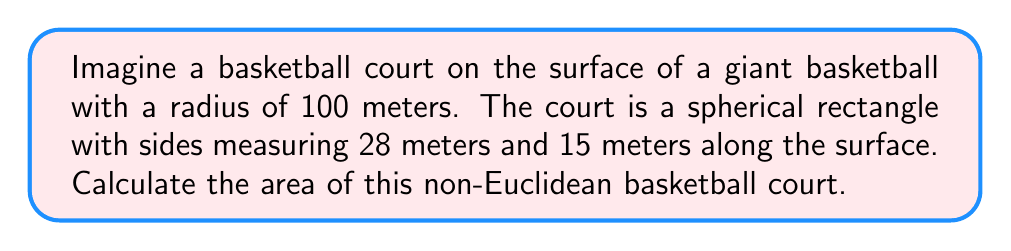Teach me how to tackle this problem. To solve this problem, we need to use the formula for the area of a spherical rectangle:

$$A = 4R^2 \arcsin(\sin(\frac{a}{2R}) \sin(\frac{b}{2R}))$$

Where:
$A$ is the area of the spherical rectangle
$R$ is the radius of the sphere
$a$ and $b$ are the side lengths of the rectangle along the surface

Given:
$R = 100$ meters
$a = 28$ meters
$b = 15$ meters

Step 1: Calculate $\frac{a}{2R}$ and $\frac{b}{2R}$
$$\frac{a}{2R} = \frac{28}{2(100)} = 0.14$$
$$\frac{b}{2R} = \frac{15}{2(100)} = 0.075$$

Step 2: Calculate $\sin(\frac{a}{2R})$ and $\sin(\frac{b}{2R})$
$$\sin(0.14) \approx 0.13949$$
$$\sin(0.075) \approx 0.07491$$

Step 3: Multiply the sine values
$$0.13949 \times 0.07491 \approx 0.01045$$

Step 4: Calculate $\arcsin$ of the result from Step 3
$$\arcsin(0.01045) \approx 0.01045$$

Step 5: Multiply by $4R^2$
$$A = 4 \times 100^2 \times 0.01045 \approx 418 \text{ m}^2$$

Therefore, the area of the non-Euclidean basketball court is approximately 418 square meters.
Answer: 418 m² 